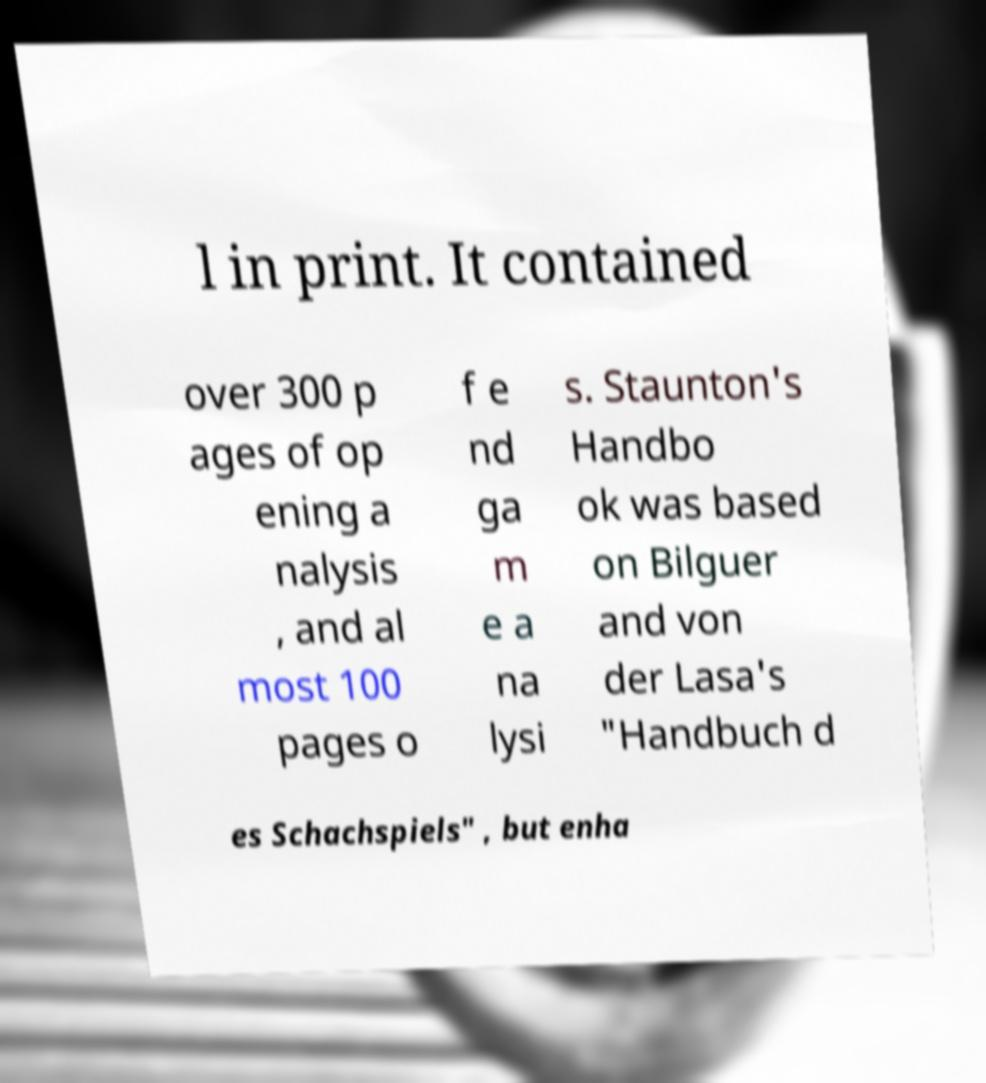Please read and relay the text visible in this image. What does it say? l in print. It contained over 300 p ages of op ening a nalysis , and al most 100 pages o f e nd ga m e a na lysi s. Staunton's Handbo ok was based on Bilguer and von der Lasa's "Handbuch d es Schachspiels" , but enha 